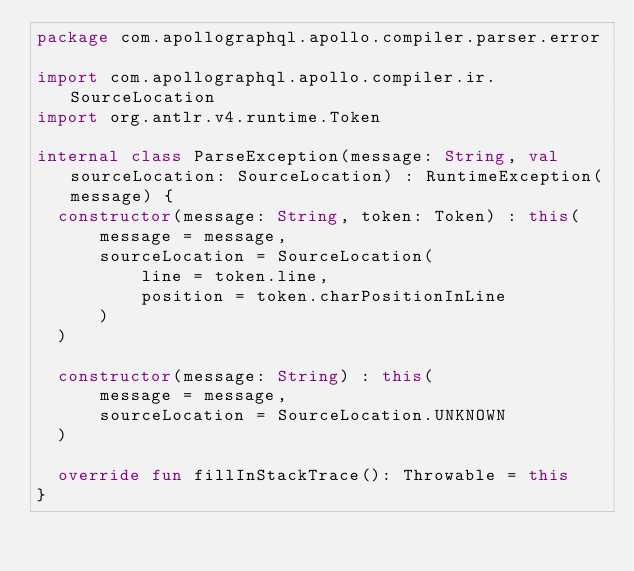<code> <loc_0><loc_0><loc_500><loc_500><_Kotlin_>package com.apollographql.apollo.compiler.parser.error

import com.apollographql.apollo.compiler.ir.SourceLocation
import org.antlr.v4.runtime.Token

internal class ParseException(message: String, val sourceLocation: SourceLocation) : RuntimeException(message) {
  constructor(message: String, token: Token) : this(
      message = message,
      sourceLocation = SourceLocation(
          line = token.line,
          position = token.charPositionInLine
      )
  )

  constructor(message: String) : this(
      message = message,
      sourceLocation = SourceLocation.UNKNOWN
  )

  override fun fillInStackTrace(): Throwable = this
}
</code> 